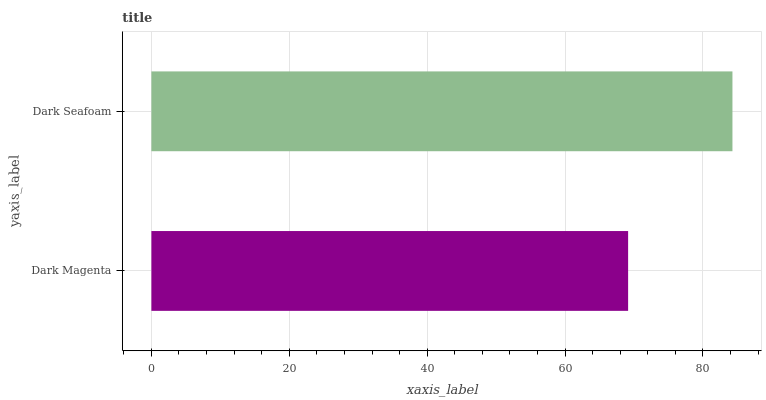Is Dark Magenta the minimum?
Answer yes or no. Yes. Is Dark Seafoam the maximum?
Answer yes or no. Yes. Is Dark Seafoam the minimum?
Answer yes or no. No. Is Dark Seafoam greater than Dark Magenta?
Answer yes or no. Yes. Is Dark Magenta less than Dark Seafoam?
Answer yes or no. Yes. Is Dark Magenta greater than Dark Seafoam?
Answer yes or no. No. Is Dark Seafoam less than Dark Magenta?
Answer yes or no. No. Is Dark Seafoam the high median?
Answer yes or no. Yes. Is Dark Magenta the low median?
Answer yes or no. Yes. Is Dark Magenta the high median?
Answer yes or no. No. Is Dark Seafoam the low median?
Answer yes or no. No. 